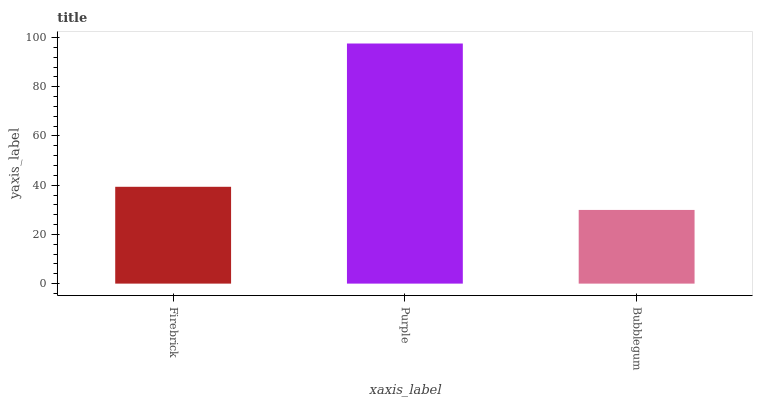Is Bubblegum the minimum?
Answer yes or no. Yes. Is Purple the maximum?
Answer yes or no. Yes. Is Purple the minimum?
Answer yes or no. No. Is Bubblegum the maximum?
Answer yes or no. No. Is Purple greater than Bubblegum?
Answer yes or no. Yes. Is Bubblegum less than Purple?
Answer yes or no. Yes. Is Bubblegum greater than Purple?
Answer yes or no. No. Is Purple less than Bubblegum?
Answer yes or no. No. Is Firebrick the high median?
Answer yes or no. Yes. Is Firebrick the low median?
Answer yes or no. Yes. Is Purple the high median?
Answer yes or no. No. Is Bubblegum the low median?
Answer yes or no. No. 